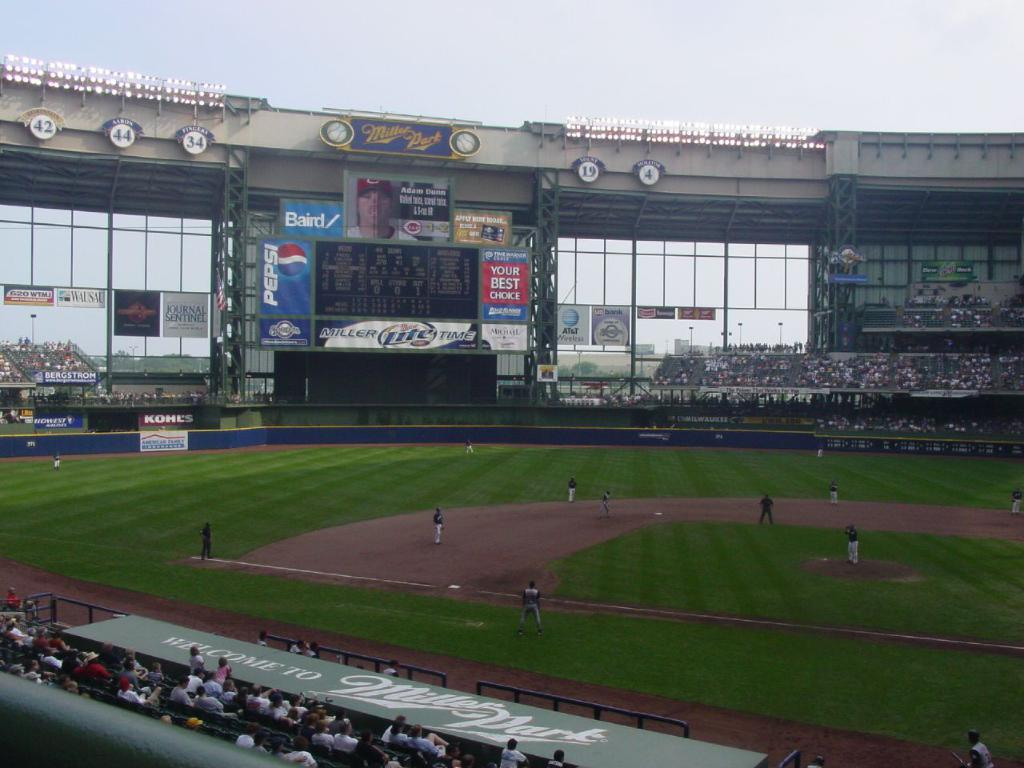<image>
Offer a succinct explanation of the picture presented. Pepsi sponsors this baseball team out on the field where fans are in the stands. 